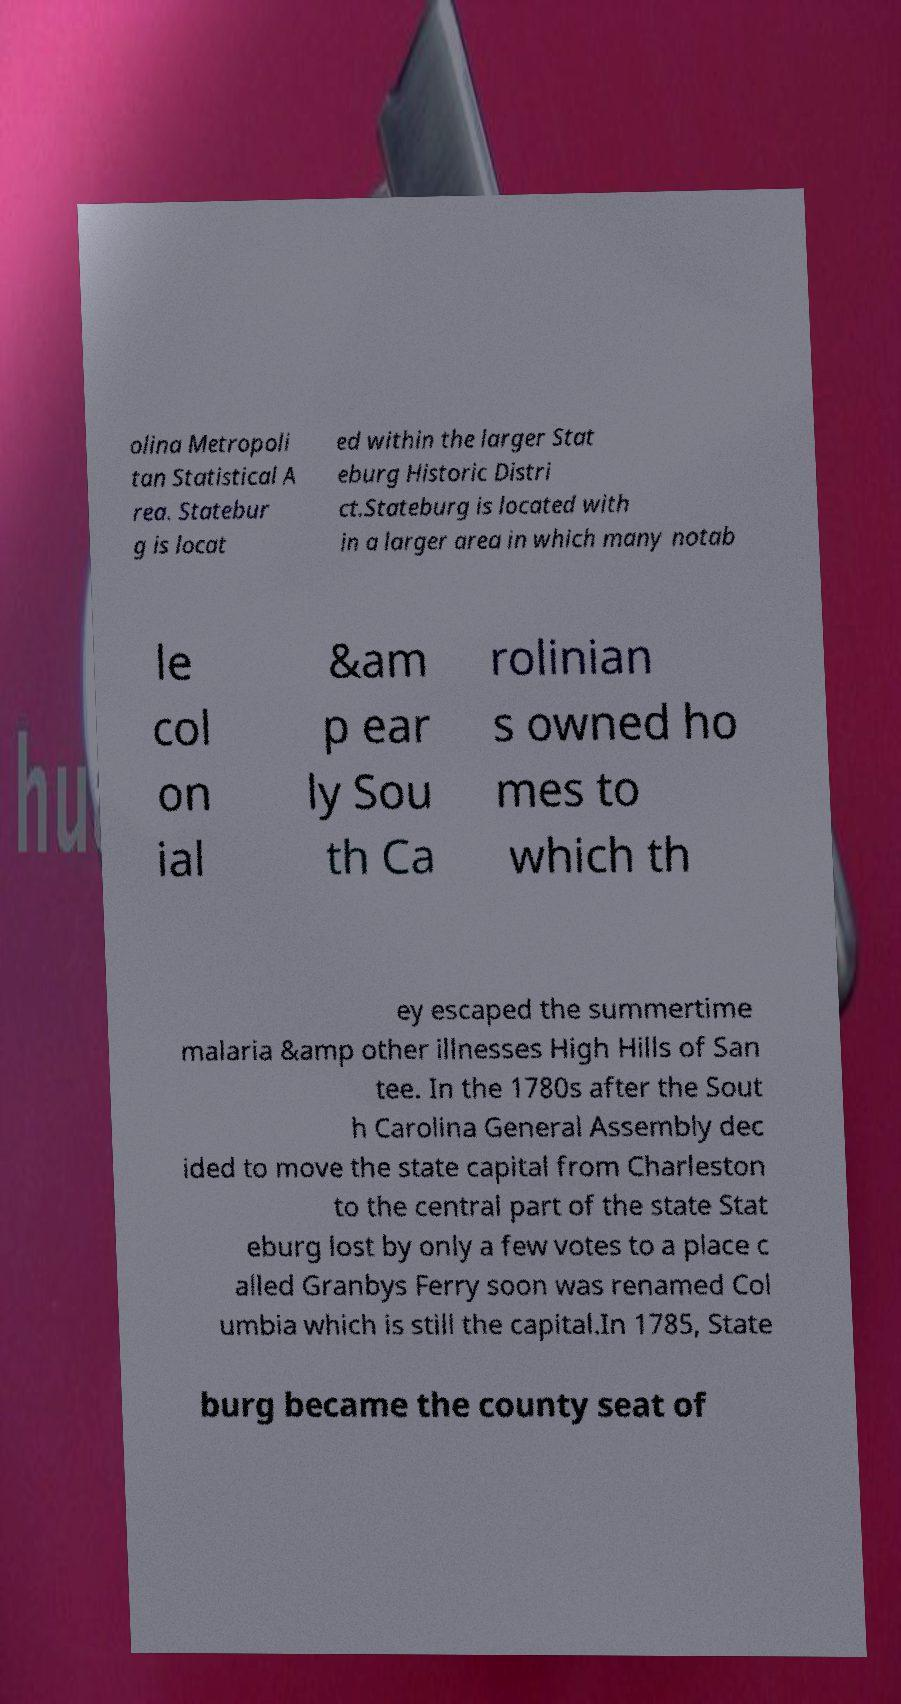Please read and relay the text visible in this image. What does it say? olina Metropoli tan Statistical A rea. Statebur g is locat ed within the larger Stat eburg Historic Distri ct.Stateburg is located with in a larger area in which many notab le col on ial &am p ear ly Sou th Ca rolinian s owned ho mes to which th ey escaped the summertime malaria &amp other illnesses High Hills of San tee. In the 1780s after the Sout h Carolina General Assembly dec ided to move the state capital from Charleston to the central part of the state Stat eburg lost by only a few votes to a place c alled Granbys Ferry soon was renamed Col umbia which is still the capital.In 1785, State burg became the county seat of 